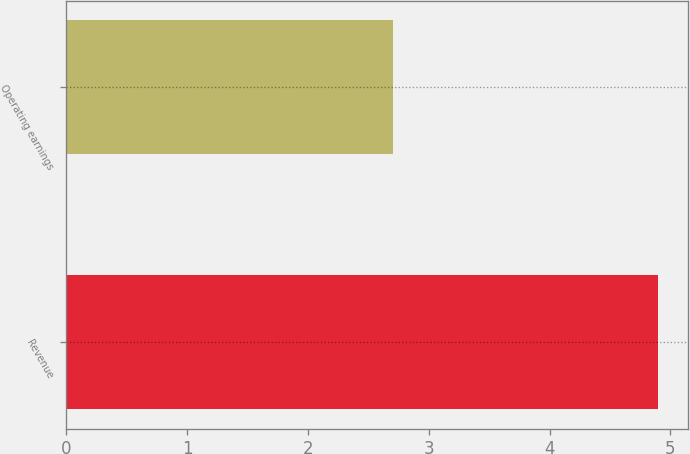<chart> <loc_0><loc_0><loc_500><loc_500><bar_chart><fcel>Revenue<fcel>Operating earnings<nl><fcel>4.9<fcel>2.7<nl></chart> 